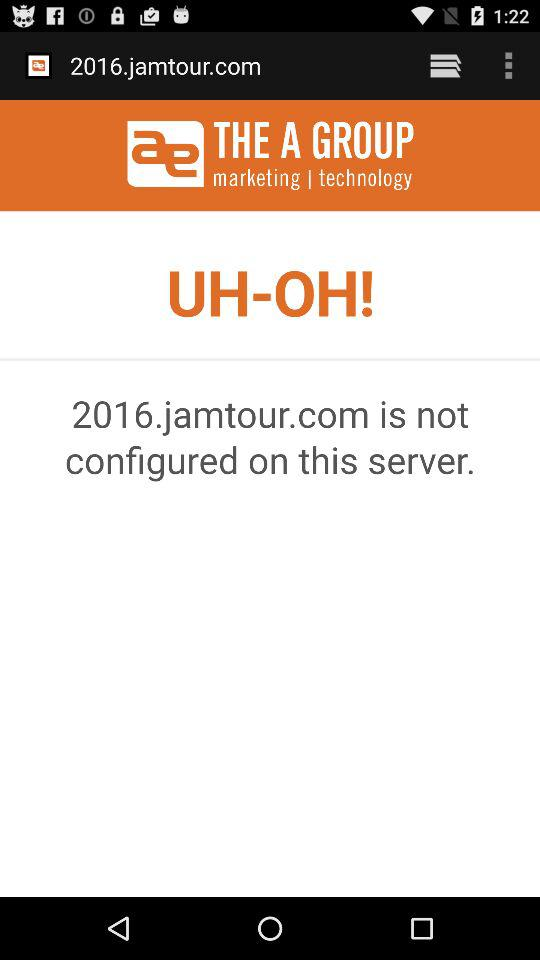What is the application name? The application name is "THE A GROUP". 